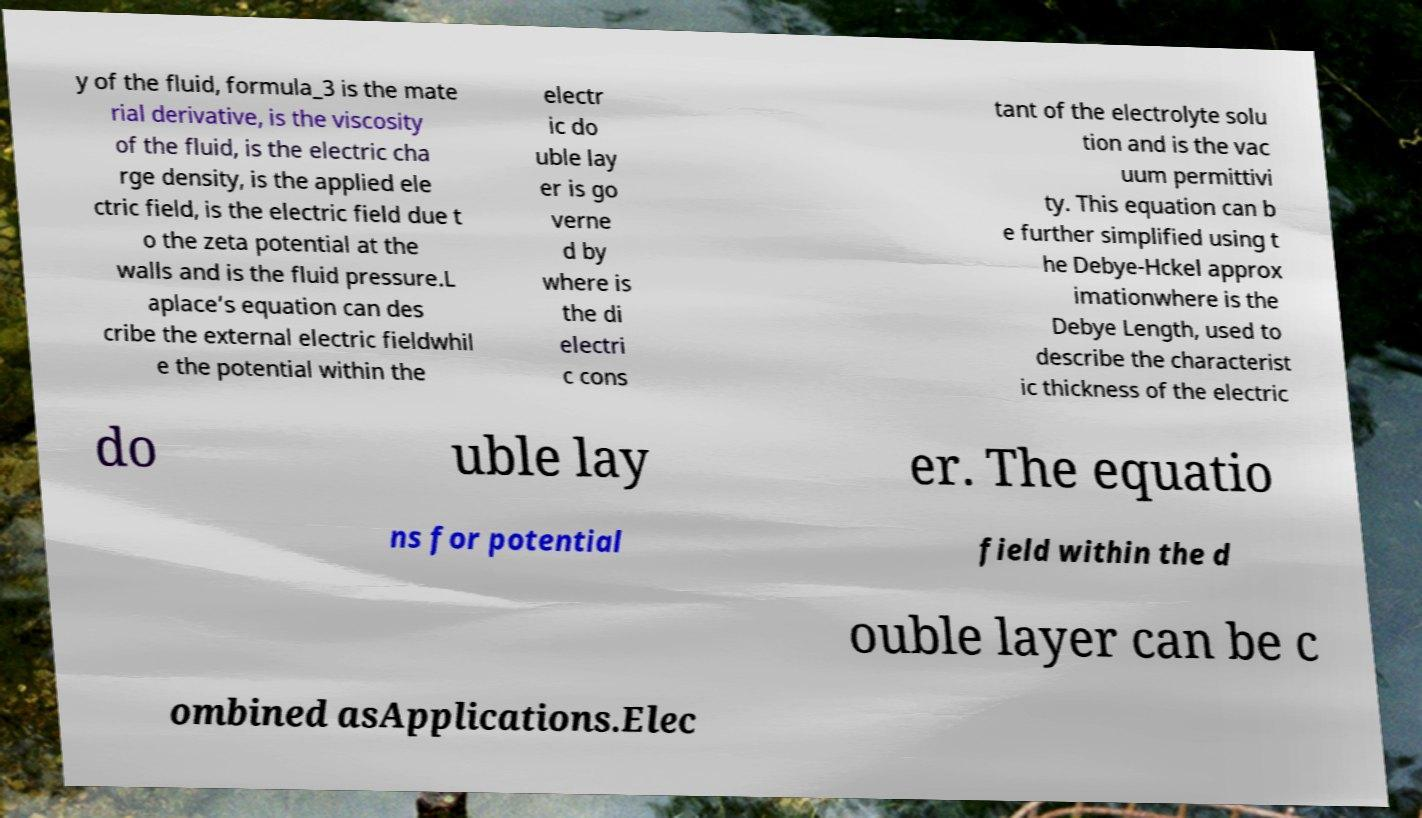Please identify and transcribe the text found in this image. y of the fluid, formula_3 is the mate rial derivative, is the viscosity of the fluid, is the electric cha rge density, is the applied ele ctric field, is the electric field due t o the zeta potential at the walls and is the fluid pressure.L aplace’s equation can des cribe the external electric fieldwhil e the potential within the electr ic do uble lay er is go verne d by where is the di electri c cons tant of the electrolyte solu tion and is the vac uum permittivi ty. This equation can b e further simplified using t he Debye-Hckel approx imationwhere is the Debye Length, used to describe the characterist ic thickness of the electric do uble lay er. The equatio ns for potential field within the d ouble layer can be c ombined asApplications.Elec 